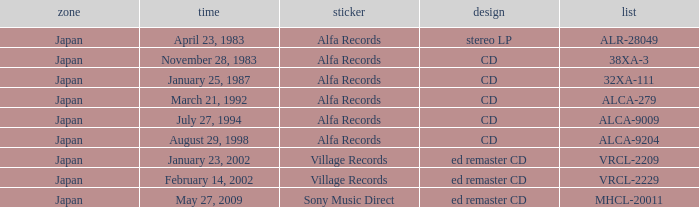Which directory is in cd format? 38XA-3, 32XA-111, ALCA-279, ALCA-9009, ALCA-9204. 